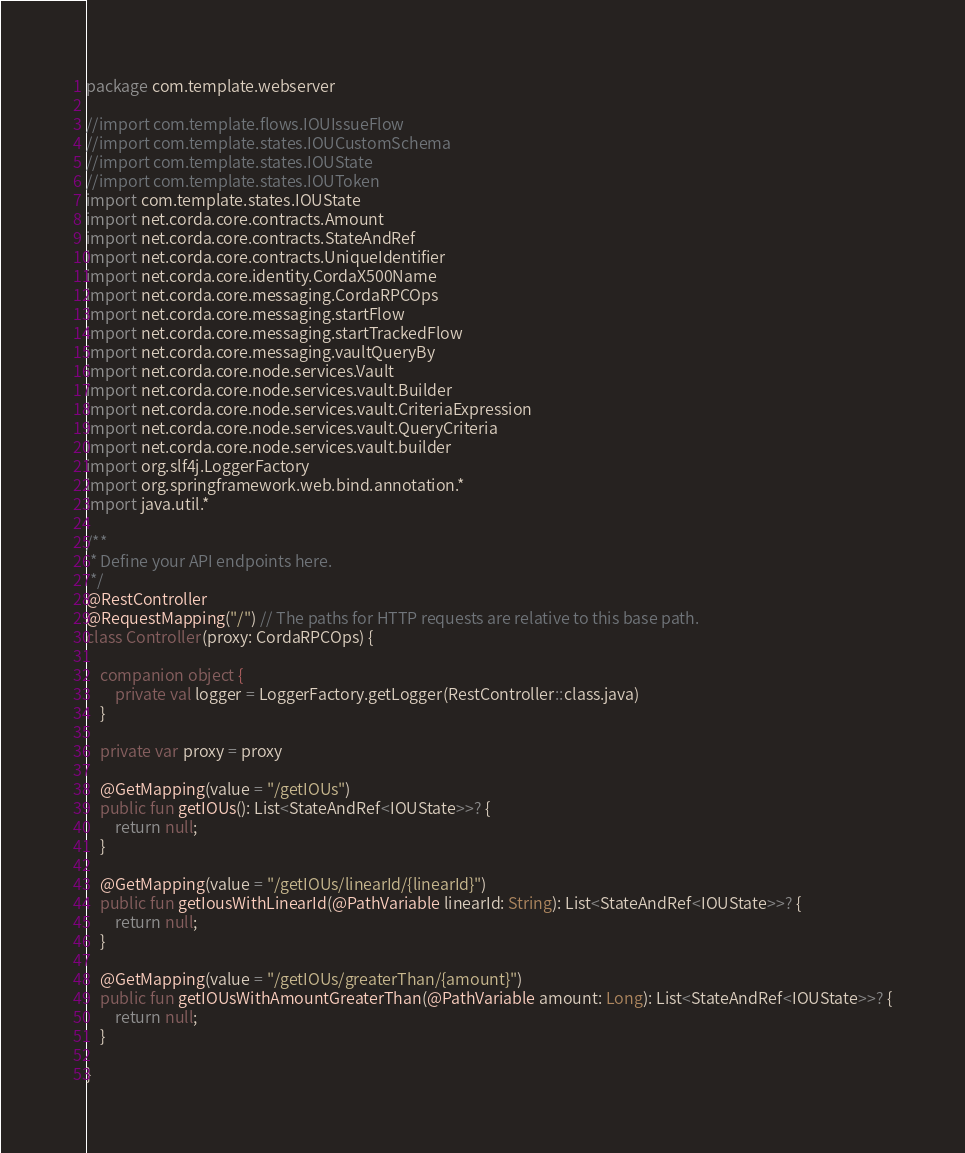<code> <loc_0><loc_0><loc_500><loc_500><_Kotlin_>package com.template.webserver

//import com.template.flows.IOUIssueFlow
//import com.template.states.IOUCustomSchema
//import com.template.states.IOUState
//import com.template.states.IOUToken
import com.template.states.IOUState
import net.corda.core.contracts.Amount
import net.corda.core.contracts.StateAndRef
import net.corda.core.contracts.UniqueIdentifier
import net.corda.core.identity.CordaX500Name
import net.corda.core.messaging.CordaRPCOps
import net.corda.core.messaging.startFlow
import net.corda.core.messaging.startTrackedFlow
import net.corda.core.messaging.vaultQueryBy
import net.corda.core.node.services.Vault
import net.corda.core.node.services.vault.Builder
import net.corda.core.node.services.vault.CriteriaExpression
import net.corda.core.node.services.vault.QueryCriteria
import net.corda.core.node.services.vault.builder
import org.slf4j.LoggerFactory
import org.springframework.web.bind.annotation.*
import java.util.*

/**
 * Define your API endpoints here.
 */
@RestController
@RequestMapping("/") // The paths for HTTP requests are relative to this base path.
class Controller(proxy: CordaRPCOps) {

    companion object {
        private val logger = LoggerFactory.getLogger(RestController::class.java)
    }

    private var proxy = proxy

    @GetMapping(value = "/getIOUs")
    public fun getIOUs(): List<StateAndRef<IOUState>>? {
        return null;
    }

    @GetMapping(value = "/getIOUs/linearId/{linearId}")
    public fun getIousWithLinearId(@PathVariable linearId: String): List<StateAndRef<IOUState>>? {
        return null;
    }

    @GetMapping(value = "/getIOUs/greaterThan/{amount}")
    public fun getIOUsWithAmountGreaterThan(@PathVariable amount: Long): List<StateAndRef<IOUState>>? {
        return null;
    }

}</code> 